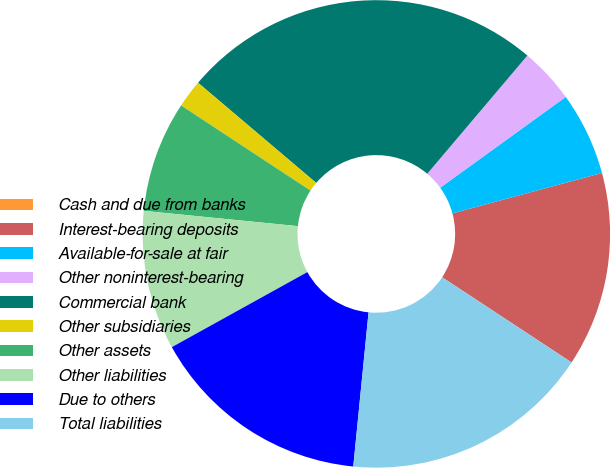Convert chart to OTSL. <chart><loc_0><loc_0><loc_500><loc_500><pie_chart><fcel>Cash and due from banks<fcel>Interest-bearing deposits<fcel>Available-for-sale at fair<fcel>Other noninterest-bearing<fcel>Commercial bank<fcel>Other subsidiaries<fcel>Other assets<fcel>Other liabilities<fcel>Due to others<fcel>Total liabilities<nl><fcel>0.01%<fcel>13.46%<fcel>5.77%<fcel>3.85%<fcel>24.99%<fcel>1.93%<fcel>7.69%<fcel>9.62%<fcel>15.38%<fcel>17.3%<nl></chart> 